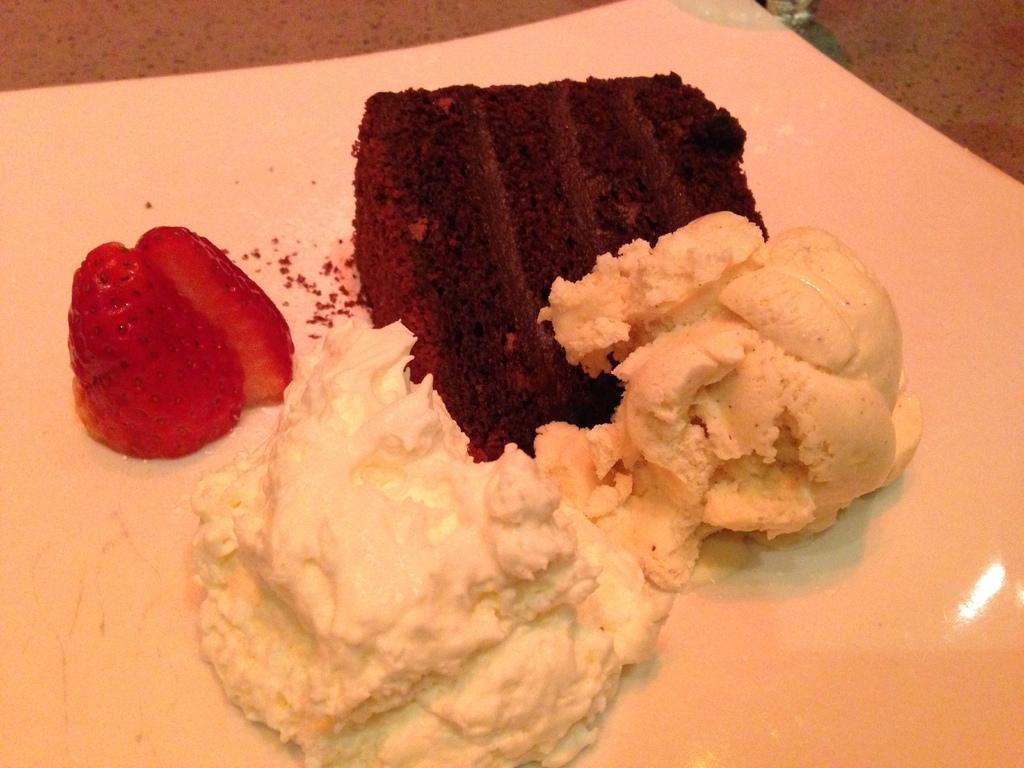Describe this image in one or two sentences. In this image, we can see desserts and there is a strawberry on the plate, which are placed on the table. 